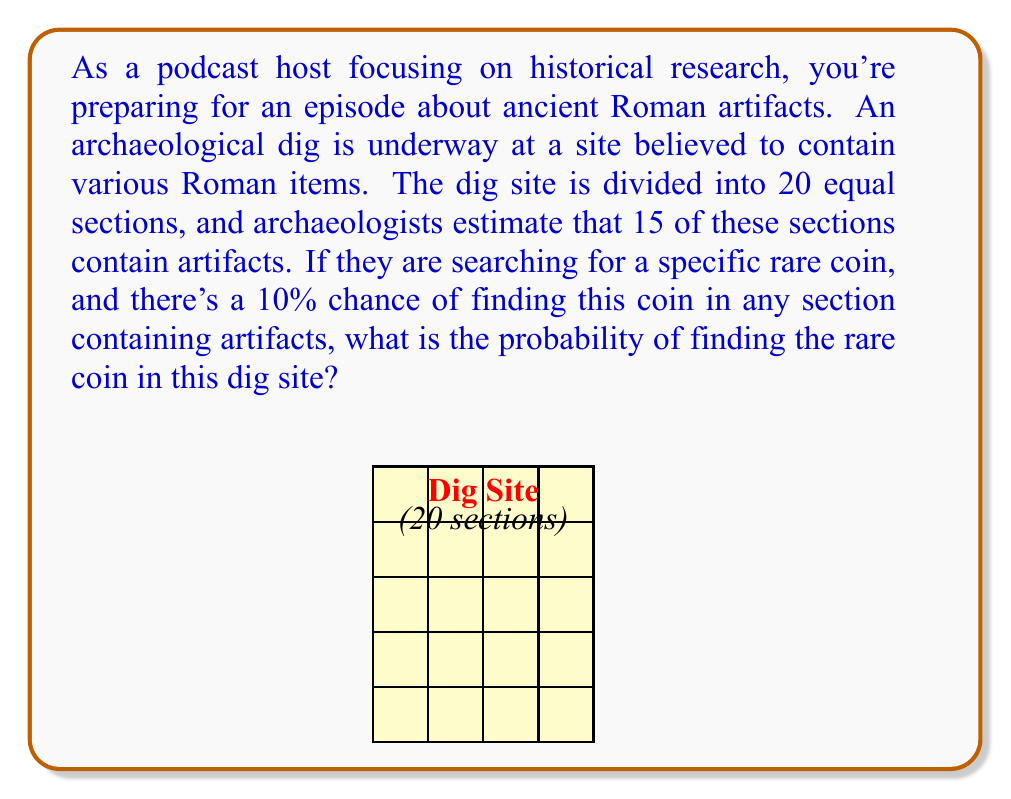Solve this math problem. Let's approach this step-by-step:

1) First, we need to understand what we're given:
   - There are 20 total sections in the dig site.
   - 15 of these sections are estimated to contain artifacts.
   - There's a 10% chance of finding the rare coin in any section with artifacts.

2) We can use the Law of Total Probability to solve this problem. We need to consider two scenarios:
   a) The probability of finding the coin in a section with artifacts
   b) The probability of finding the coin in a section without artifacts

3) Let's define our events:
   A: Finding the rare coin
   B: Section contains artifacts

4) We can write our probability as:
   $$P(A) = P(A|B) \cdot P(B) + P(A|\text{not }B) \cdot P(\text{not }B)$$

5) Now, let's fill in what we know:
   - $P(A|B) = 0.10$ (10% chance of finding the coin in a section with artifacts)
   - $P(B) = 15/20 = 0.75$ (15 out of 20 sections contain artifacts)
   - $P(\text{not }B) = 1 - P(B) = 1 - 0.75 = 0.25$
   - $P(A|\text{not }B) = 0$ (Can't find the coin in a section without artifacts)

6) Plugging these values into our equation:
   $$P(A) = 0.10 \cdot 0.75 + 0 \cdot 0.25 = 0.075$$

7) Therefore, the probability of finding the rare coin in this dig site is 0.075 or 7.5%.
Answer: $0.075$ or $7.5\%$ 